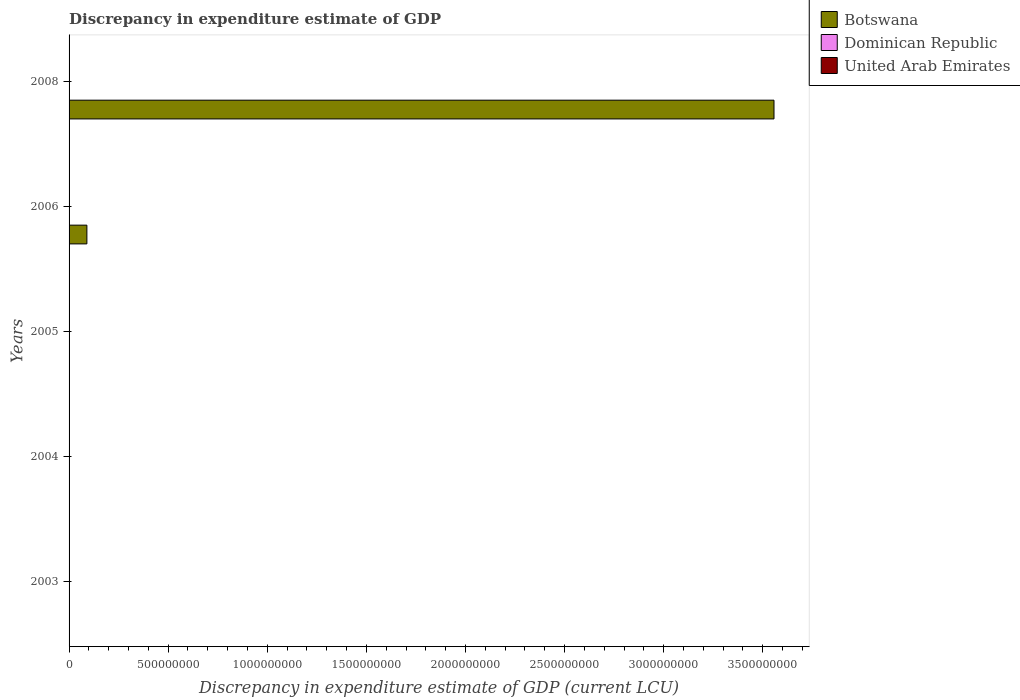How many different coloured bars are there?
Provide a succinct answer. 3. Are the number of bars per tick equal to the number of legend labels?
Offer a very short reply. No. How many bars are there on the 5th tick from the top?
Ensure brevity in your answer.  0. What is the label of the 1st group of bars from the top?
Ensure brevity in your answer.  2008. In how many cases, is the number of bars for a given year not equal to the number of legend labels?
Provide a succinct answer. 4. Across all years, what is the maximum discrepancy in expenditure estimate of GDP in United Arab Emirates?
Keep it short and to the point. 1.00e+06. Across all years, what is the minimum discrepancy in expenditure estimate of GDP in United Arab Emirates?
Provide a succinct answer. 0. What is the total discrepancy in expenditure estimate of GDP in United Arab Emirates in the graph?
Offer a very short reply. 2.00e+06. What is the difference between the discrepancy in expenditure estimate of GDP in Dominican Republic in 2004 and that in 2005?
Your response must be concise. 0. What is the difference between the discrepancy in expenditure estimate of GDP in United Arab Emirates in 2006 and the discrepancy in expenditure estimate of GDP in Botswana in 2003?
Offer a very short reply. 1.00e+06. What is the average discrepancy in expenditure estimate of GDP in Dominican Republic per year?
Give a very brief answer. 11.07. In the year 2006, what is the difference between the discrepancy in expenditure estimate of GDP in United Arab Emirates and discrepancy in expenditure estimate of GDP in Dominican Republic?
Make the answer very short. 1.00e+06. In how many years, is the discrepancy in expenditure estimate of GDP in Botswana greater than 400000000 LCU?
Make the answer very short. 1. What is the ratio of the discrepancy in expenditure estimate of GDP in United Arab Emirates in 2004 to that in 2006?
Give a very brief answer. 1. What is the difference between the highest and the second highest discrepancy in expenditure estimate of GDP in Dominican Republic?
Keep it short and to the point. 55.34. What is the difference between the highest and the lowest discrepancy in expenditure estimate of GDP in Botswana?
Provide a succinct answer. 3.56e+09. In how many years, is the discrepancy in expenditure estimate of GDP in Dominican Republic greater than the average discrepancy in expenditure estimate of GDP in Dominican Republic taken over all years?
Keep it short and to the point. 1. Is the sum of the discrepancy in expenditure estimate of GDP in Dominican Republic in 2004 and 2006 greater than the maximum discrepancy in expenditure estimate of GDP in United Arab Emirates across all years?
Ensure brevity in your answer.  No. How many bars are there?
Give a very brief answer. 9. Are all the bars in the graph horizontal?
Your answer should be compact. Yes. How many years are there in the graph?
Provide a short and direct response. 5. What is the difference between two consecutive major ticks on the X-axis?
Make the answer very short. 5.00e+08. Are the values on the major ticks of X-axis written in scientific E-notation?
Your answer should be very brief. No. Does the graph contain grids?
Your response must be concise. No. Where does the legend appear in the graph?
Ensure brevity in your answer.  Top right. How many legend labels are there?
Ensure brevity in your answer.  3. How are the legend labels stacked?
Ensure brevity in your answer.  Vertical. What is the title of the graph?
Provide a short and direct response. Discrepancy in expenditure estimate of GDP. Does "Luxembourg" appear as one of the legend labels in the graph?
Give a very brief answer. No. What is the label or title of the X-axis?
Provide a short and direct response. Discrepancy in expenditure estimate of GDP (current LCU). What is the label or title of the Y-axis?
Your answer should be compact. Years. What is the Discrepancy in expenditure estimate of GDP (current LCU) in Botswana in 2003?
Offer a terse response. 0. What is the Discrepancy in expenditure estimate of GDP (current LCU) of Botswana in 2004?
Provide a short and direct response. 0. What is the Discrepancy in expenditure estimate of GDP (current LCU) of Dominican Republic in 2004?
Offer a terse response. 0. What is the Discrepancy in expenditure estimate of GDP (current LCU) of United Arab Emirates in 2004?
Make the answer very short. 1.00e+06. What is the Discrepancy in expenditure estimate of GDP (current LCU) in Botswana in 2005?
Provide a short and direct response. 0. What is the Discrepancy in expenditure estimate of GDP (current LCU) in Dominican Republic in 2005?
Make the answer very short. 8e-6. What is the Discrepancy in expenditure estimate of GDP (current LCU) in United Arab Emirates in 2005?
Make the answer very short. 8e-6. What is the Discrepancy in expenditure estimate of GDP (current LCU) in Botswana in 2006?
Offer a terse response. 8.99e+07. What is the Discrepancy in expenditure estimate of GDP (current LCU) of Dominican Republic in 2006?
Ensure brevity in your answer.  0. What is the Discrepancy in expenditure estimate of GDP (current LCU) in United Arab Emirates in 2006?
Your response must be concise. 1.00e+06. What is the Discrepancy in expenditure estimate of GDP (current LCU) of Botswana in 2008?
Give a very brief answer. 3.56e+09. What is the Discrepancy in expenditure estimate of GDP (current LCU) in Dominican Republic in 2008?
Make the answer very short. 55.34. What is the Discrepancy in expenditure estimate of GDP (current LCU) of United Arab Emirates in 2008?
Your answer should be very brief. 0. Across all years, what is the maximum Discrepancy in expenditure estimate of GDP (current LCU) of Botswana?
Ensure brevity in your answer.  3.56e+09. Across all years, what is the maximum Discrepancy in expenditure estimate of GDP (current LCU) in Dominican Republic?
Provide a short and direct response. 55.34. Across all years, what is the maximum Discrepancy in expenditure estimate of GDP (current LCU) in United Arab Emirates?
Your answer should be compact. 1.00e+06. Across all years, what is the minimum Discrepancy in expenditure estimate of GDP (current LCU) in Botswana?
Your answer should be compact. 0. What is the total Discrepancy in expenditure estimate of GDP (current LCU) of Botswana in the graph?
Your answer should be compact. 3.65e+09. What is the total Discrepancy in expenditure estimate of GDP (current LCU) of Dominican Republic in the graph?
Give a very brief answer. 55.34. What is the total Discrepancy in expenditure estimate of GDP (current LCU) of United Arab Emirates in the graph?
Offer a very short reply. 2.00e+06. What is the difference between the Discrepancy in expenditure estimate of GDP (current LCU) of United Arab Emirates in 2004 and that in 2005?
Give a very brief answer. 1.00e+06. What is the difference between the Discrepancy in expenditure estimate of GDP (current LCU) of Dominican Republic in 2004 and that in 2008?
Provide a short and direct response. -55.34. What is the difference between the Discrepancy in expenditure estimate of GDP (current LCU) in Dominican Republic in 2005 and that in 2006?
Provide a short and direct response. -0. What is the difference between the Discrepancy in expenditure estimate of GDP (current LCU) of United Arab Emirates in 2005 and that in 2006?
Offer a very short reply. -1.00e+06. What is the difference between the Discrepancy in expenditure estimate of GDP (current LCU) of Dominican Republic in 2005 and that in 2008?
Provide a succinct answer. -55.34. What is the difference between the Discrepancy in expenditure estimate of GDP (current LCU) in Botswana in 2006 and that in 2008?
Provide a succinct answer. -3.47e+09. What is the difference between the Discrepancy in expenditure estimate of GDP (current LCU) of Dominican Republic in 2006 and that in 2008?
Ensure brevity in your answer.  -55.34. What is the difference between the Discrepancy in expenditure estimate of GDP (current LCU) of Dominican Republic in 2004 and the Discrepancy in expenditure estimate of GDP (current LCU) of United Arab Emirates in 2005?
Offer a very short reply. 0. What is the difference between the Discrepancy in expenditure estimate of GDP (current LCU) in Dominican Republic in 2004 and the Discrepancy in expenditure estimate of GDP (current LCU) in United Arab Emirates in 2006?
Your answer should be compact. -1.00e+06. What is the difference between the Discrepancy in expenditure estimate of GDP (current LCU) in Botswana in 2006 and the Discrepancy in expenditure estimate of GDP (current LCU) in Dominican Republic in 2008?
Offer a very short reply. 8.99e+07. What is the average Discrepancy in expenditure estimate of GDP (current LCU) of Botswana per year?
Make the answer very short. 7.29e+08. What is the average Discrepancy in expenditure estimate of GDP (current LCU) of Dominican Republic per year?
Offer a very short reply. 11.07. In the year 2004, what is the difference between the Discrepancy in expenditure estimate of GDP (current LCU) in Dominican Republic and Discrepancy in expenditure estimate of GDP (current LCU) in United Arab Emirates?
Ensure brevity in your answer.  -1.00e+06. In the year 2006, what is the difference between the Discrepancy in expenditure estimate of GDP (current LCU) of Botswana and Discrepancy in expenditure estimate of GDP (current LCU) of Dominican Republic?
Provide a short and direct response. 8.99e+07. In the year 2006, what is the difference between the Discrepancy in expenditure estimate of GDP (current LCU) of Botswana and Discrepancy in expenditure estimate of GDP (current LCU) of United Arab Emirates?
Ensure brevity in your answer.  8.89e+07. In the year 2006, what is the difference between the Discrepancy in expenditure estimate of GDP (current LCU) in Dominican Republic and Discrepancy in expenditure estimate of GDP (current LCU) in United Arab Emirates?
Ensure brevity in your answer.  -1.00e+06. In the year 2008, what is the difference between the Discrepancy in expenditure estimate of GDP (current LCU) of Botswana and Discrepancy in expenditure estimate of GDP (current LCU) of Dominican Republic?
Offer a very short reply. 3.56e+09. What is the ratio of the Discrepancy in expenditure estimate of GDP (current LCU) of United Arab Emirates in 2004 to that in 2005?
Give a very brief answer. 1.25e+11. What is the ratio of the Discrepancy in expenditure estimate of GDP (current LCU) of Dominican Republic in 2004 to that in 2006?
Your answer should be compact. 1. What is the ratio of the Discrepancy in expenditure estimate of GDP (current LCU) in Dominican Republic in 2004 to that in 2008?
Provide a short and direct response. 0. What is the ratio of the Discrepancy in expenditure estimate of GDP (current LCU) of Dominican Republic in 2005 to that in 2006?
Offer a very short reply. 0.07. What is the ratio of the Discrepancy in expenditure estimate of GDP (current LCU) of Botswana in 2006 to that in 2008?
Provide a succinct answer. 0.03. What is the ratio of the Discrepancy in expenditure estimate of GDP (current LCU) in Dominican Republic in 2006 to that in 2008?
Offer a very short reply. 0. What is the difference between the highest and the second highest Discrepancy in expenditure estimate of GDP (current LCU) of Dominican Republic?
Your answer should be compact. 55.34. What is the difference between the highest and the second highest Discrepancy in expenditure estimate of GDP (current LCU) of United Arab Emirates?
Offer a terse response. 0. What is the difference between the highest and the lowest Discrepancy in expenditure estimate of GDP (current LCU) of Botswana?
Give a very brief answer. 3.56e+09. What is the difference between the highest and the lowest Discrepancy in expenditure estimate of GDP (current LCU) in Dominican Republic?
Offer a terse response. 55.34. What is the difference between the highest and the lowest Discrepancy in expenditure estimate of GDP (current LCU) of United Arab Emirates?
Offer a terse response. 1.00e+06. 